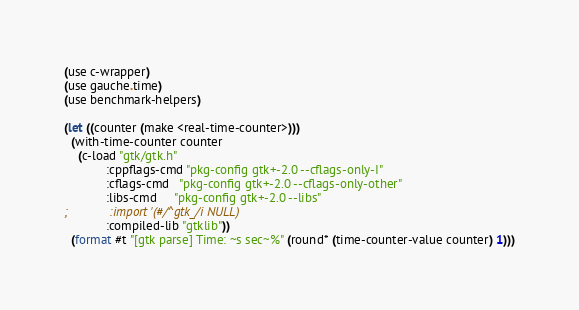<code> <loc_0><loc_0><loc_500><loc_500><_Scheme_>(use c-wrapper)
(use gauche.time)
(use benchmark-helpers)

(let ((counter (make <real-time-counter>)))
  (with-time-counter counter
    (c-load "gtk/gtk.h"
            :cppflags-cmd "pkg-config gtk+-2.0 --cflags-only-I"
            :cflags-cmd   "pkg-config gtk+-2.0 --cflags-only-other"
            :libs-cmd     "pkg-config gtk+-2.0 --libs"
;            :import '(#/^gtk_/i NULL)
            :compiled-lib "gtklib"))
  (format #t "[gtk parse] Time: ~s sec~%" (round* (time-counter-value counter) 1)))

</code> 